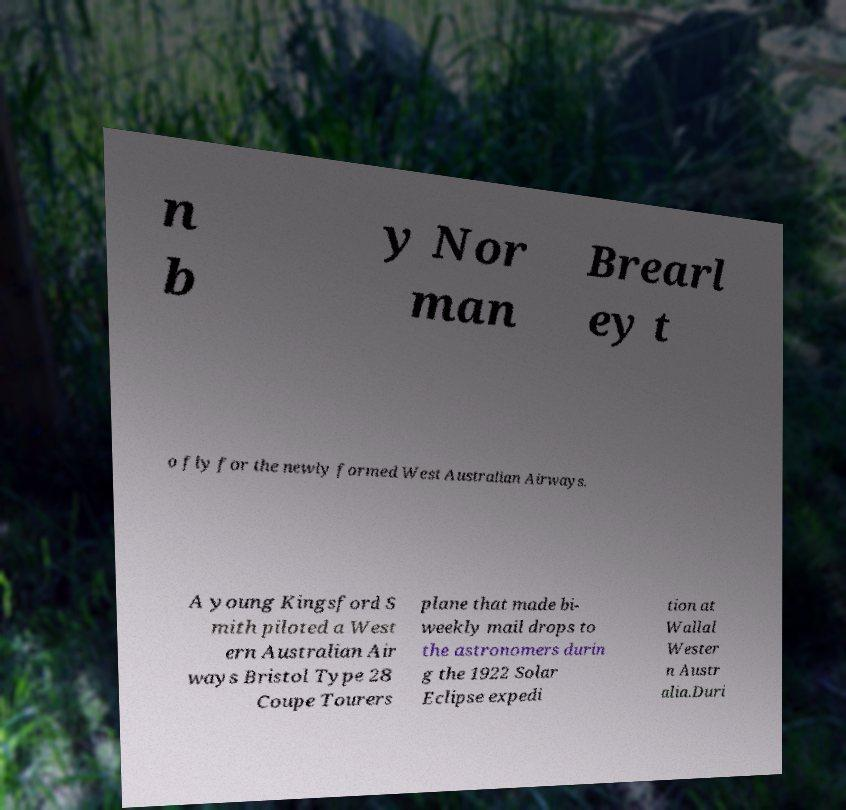Could you extract and type out the text from this image? n b y Nor man Brearl ey t o fly for the newly formed West Australian Airways. A young Kingsford S mith piloted a West ern Australian Air ways Bristol Type 28 Coupe Tourers plane that made bi- weekly mail drops to the astronomers durin g the 1922 Solar Eclipse expedi tion at Wallal Wester n Austr alia.Duri 